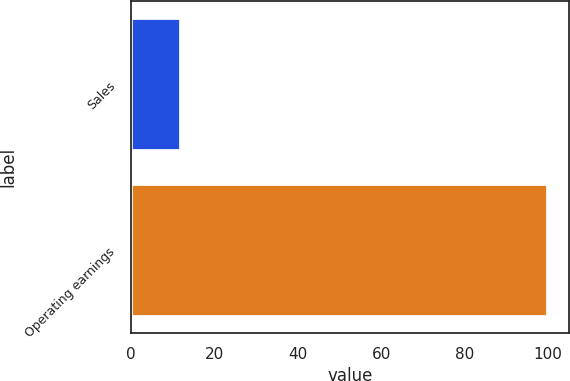Convert chart to OTSL. <chart><loc_0><loc_0><loc_500><loc_500><bar_chart><fcel>Sales<fcel>Operating earnings<nl><fcel>12<fcel>100<nl></chart> 